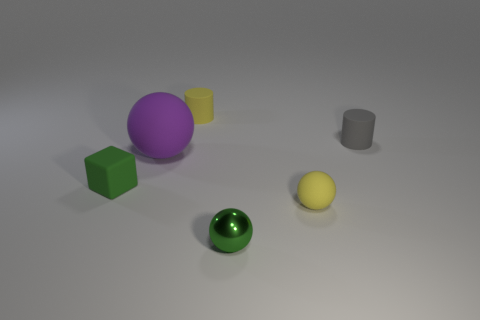How is light interacting with the objects in the scene? Light highlights the reflective nature of the green sphere and the metal object, creating bright spots and reflections which indicate a smooth surface. The purple sphere and the yellow cylinder cast soft shadows, and the light diffuses evenly over the matte and textured surfaces, providing a sense of depth and material contrast in the scene. 